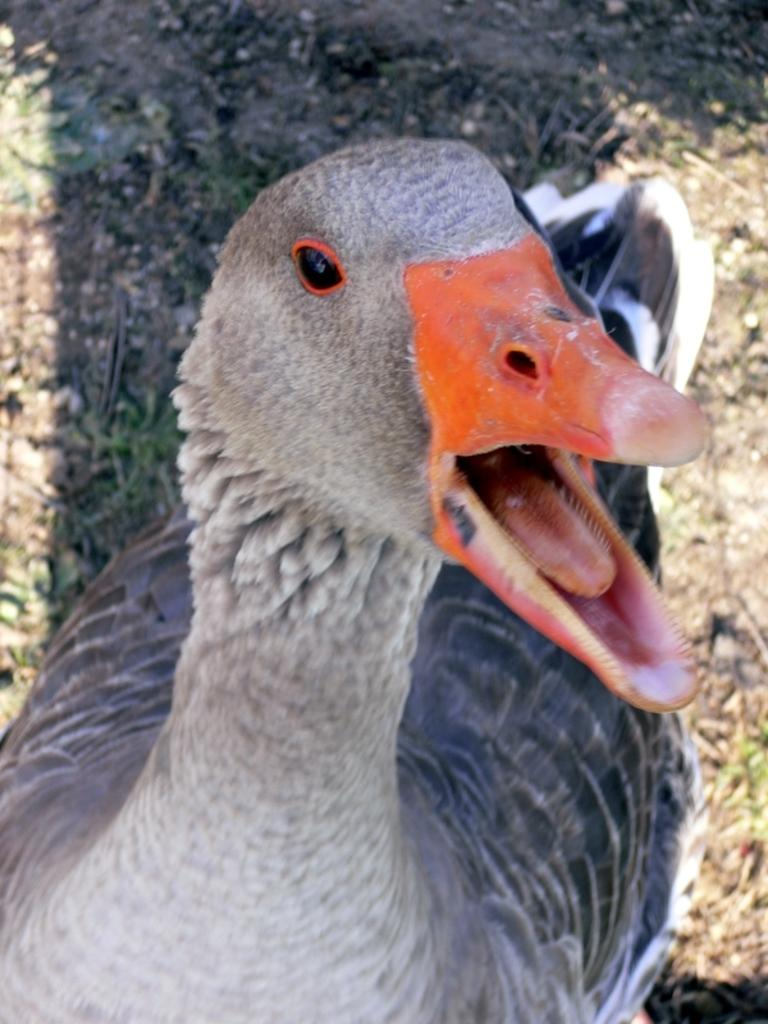What is the main object in the image? There is a duct in the image. What is the duct doing in the image? The duct appears to be opening its mouth. What type of surface is visible in the image? There is ground visible in the image. What can be found on the ground in the image? Stones are present on the ground. What type of butter is being used by the duct in the image? There is no butter present in the image, and the duct is not using any butter. 